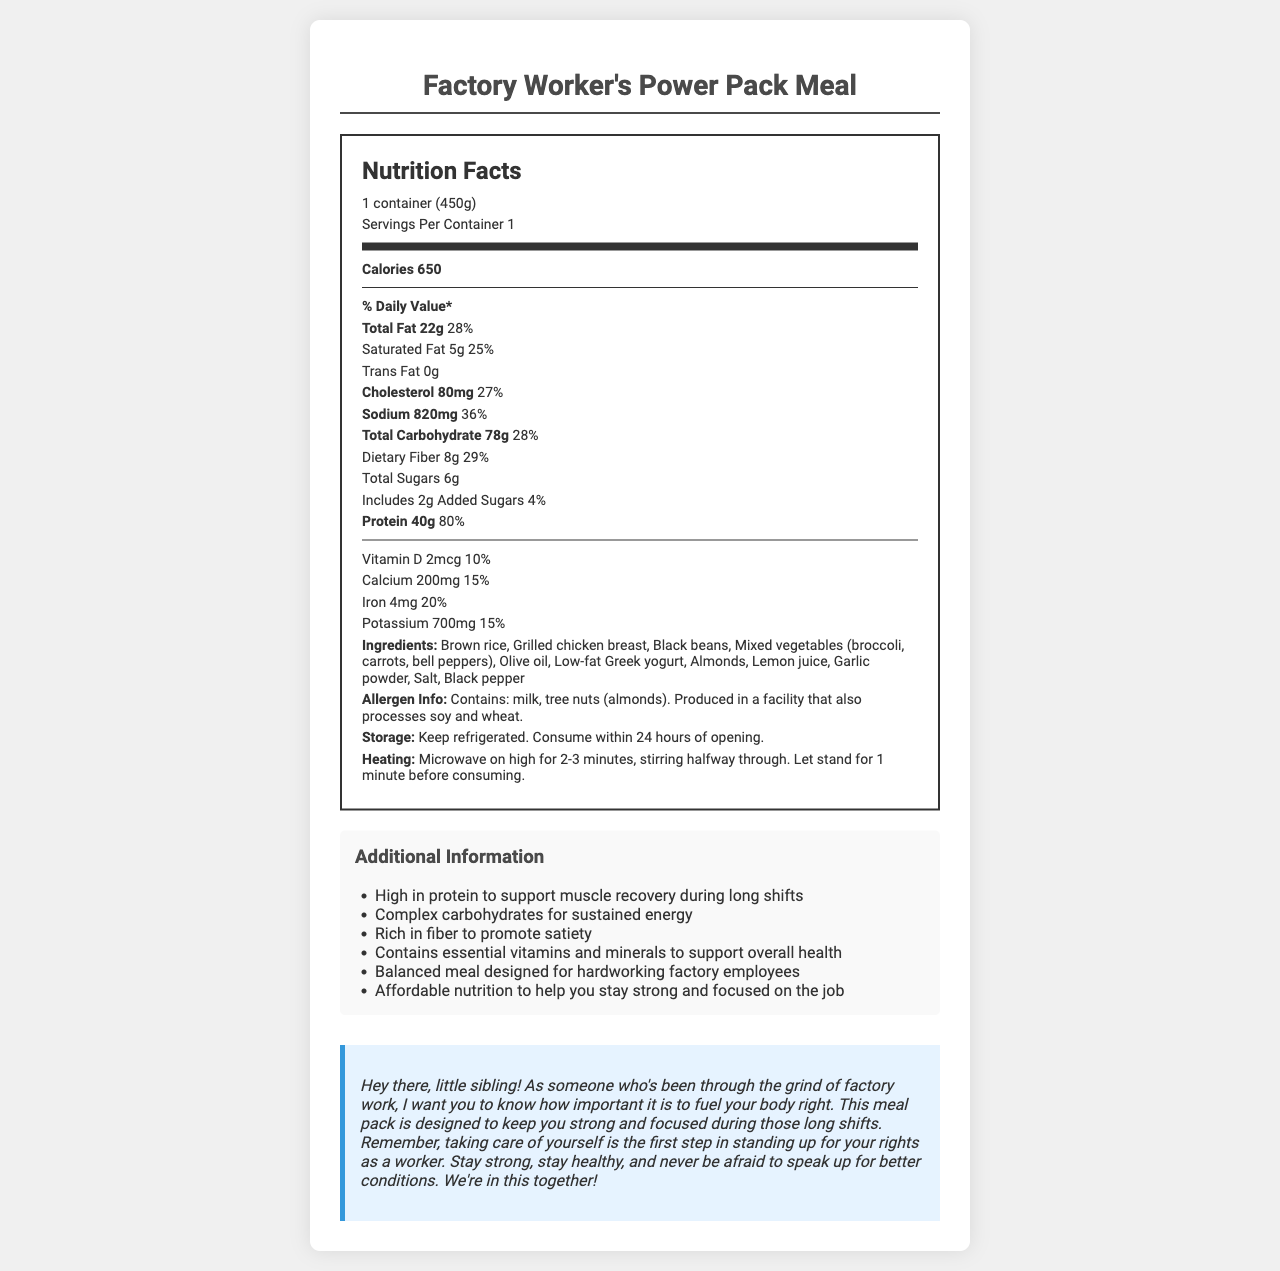How many calories does the Factory Worker's Power Pack Meal contain? The document explicitly states that the meal contains 650 calories.
Answer: 650 What is the serving size for the Factory Worker's Power Pack Meal? The serving size is given as 1 container (450g) in the document.
Answer: 1 container (450g) How much total fat does one serving of the meal have? The document lists the total fat content as 22g per serving.
Answer: 22g What is the percentage of the daily value for protein in the meal? The daily value percentage for protein is shown in the document as 80%.
Answer: 80% Which two allergens are mentioned in the allergen information? The document specifies that the meal contains milk and tree nuts (almonds).
Answer: Milk, almonds What is the value of sodium in the meal? A. 300mg B. 620mg C. 820mg D. 920mg The sodium content is detailed in the document as 820mg.
Answer: C. 820mg How much dietary fiber does the meal offer? The document indicates that there are 8g of dietary fiber in the meal.
Answer: 8g Does the meal contain any trans fat? The document states that the trans fat amount is 0g.
Answer: No What are the ingredients of the Factory Worker's Power Pack Meal? The ingredients are listed at the bottom of the document.
Answer: Brown rice, Grilled chicken breast, Black beans, Mixed vegetables (broccoli, carrots, bell peppers), Olive oil, Low-fat Greek yogurt, Almonds, Lemon juice, Garlic powder, Salt, Black pepper Which of the following is NOT in the ingredients list? A. Broccoli B. Carrots C. Tomato D. Almonds Tomato is not listed among the ingredients in the document.
Answer: C. Tomato Does this meal help support muscle recovery? The additional info section mentions that the meal is high in protein to support muscle recovery.
Answer: Yes What is the heating instruction for this meal? The document provides this specific method for heating the meal.
Answer: Microwave on high for 2-3 minutes, stirring halfway through. Let stand for 1 minute before consuming. Which vitamin/mineral has the highest daily value percentage in the meal, and what is it? Out of all the vitamins and minerals listed, Protein has the highest daily value percentage of 80%.
Answer: Protein, 80% Can I store the meal at room temperature? The document states that the meal should be kept refrigerated.
Answer: No Summarize the main purpose of this nutrition label and document. The document includes diverse sections—nutrition facts, ingredients, additional info, and a heartfelt message emphasizing the importance of proper nutrition for long work shifts and worker advocacy, encapsulating the main purpose.
Answer: The document provides nutritional details and additional information about the Factory Worker's Power Pack Meal, focusing on its high protein content, complex carbohydrates, and essential vitamins and minerals, designed to support factory workers during long shifts. It emphasizes affordability and balanced nutrition, includes allergen and storage information, and adds a personal message for worker encouragement. What is not mentioned about the Olive oil used in the meal? The document does not specify the type or brand of Olive oil used in the meal.
Answer: The specific type or brand of Olive oil 